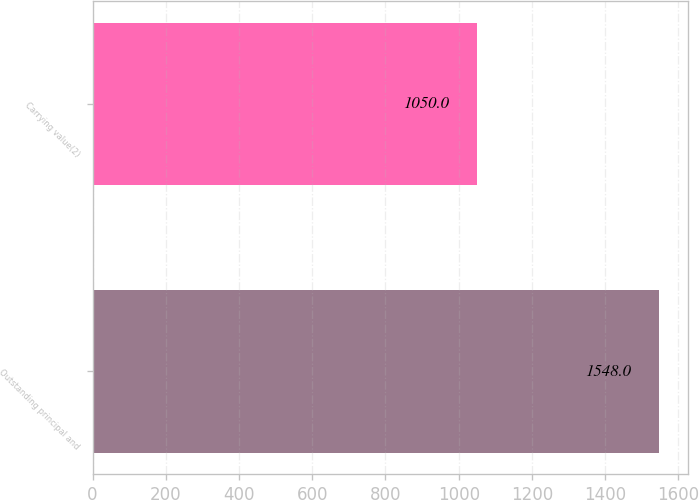Convert chart to OTSL. <chart><loc_0><loc_0><loc_500><loc_500><bar_chart><fcel>Outstanding principal and<fcel>Carrying value(2)<nl><fcel>1548<fcel>1050<nl></chart> 